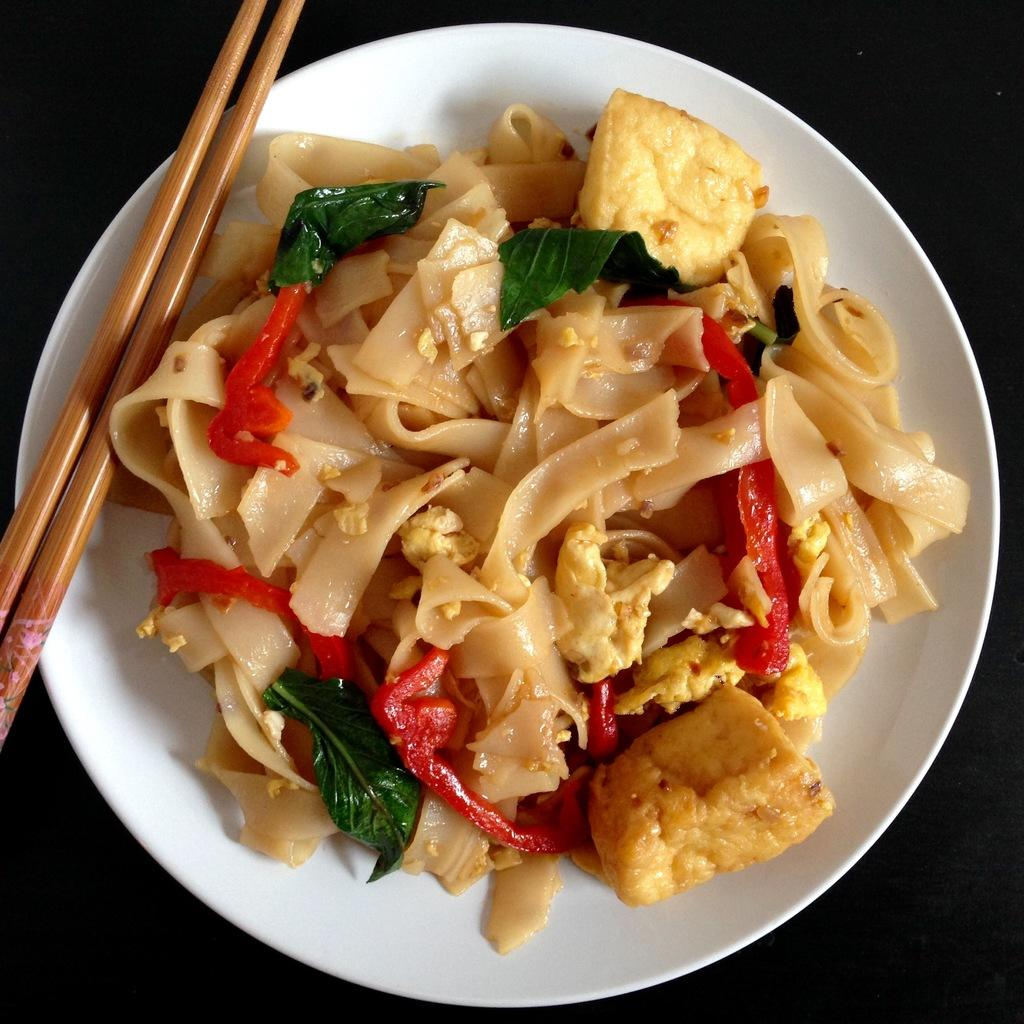What type of food is served on the plate in the image? There is pasta served on a plate in the image. What utensils are visible in the image? Chopsticks are on the left side of the image. What is the color of the surface in the image? The image has a black surface. What design is featured on the stamp in the image? There is no stamp present in the image. What theory is being discussed by the people in the image? There are no people or discussions in the image. 